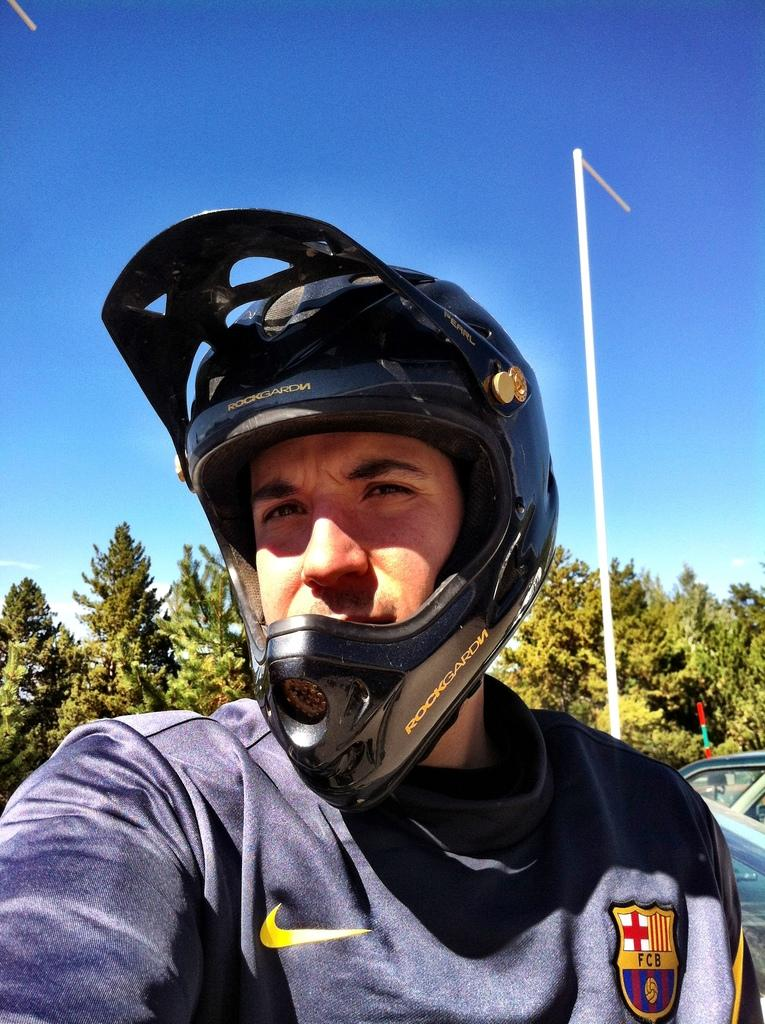What is the person in the image wearing on their head? The person in the image is wearing a helmet. What is located behind the person? There is a pole and a vehicle visible behind the person. What can be seen in the background of the image? There are trees and the sky visible in the background of the image. What type of bean is growing on the slope in the image? There is no bean or slope present in the image; it features a person wearing a helmet with a pole and a vehicle behind them, along with trees and the sky in the background. 